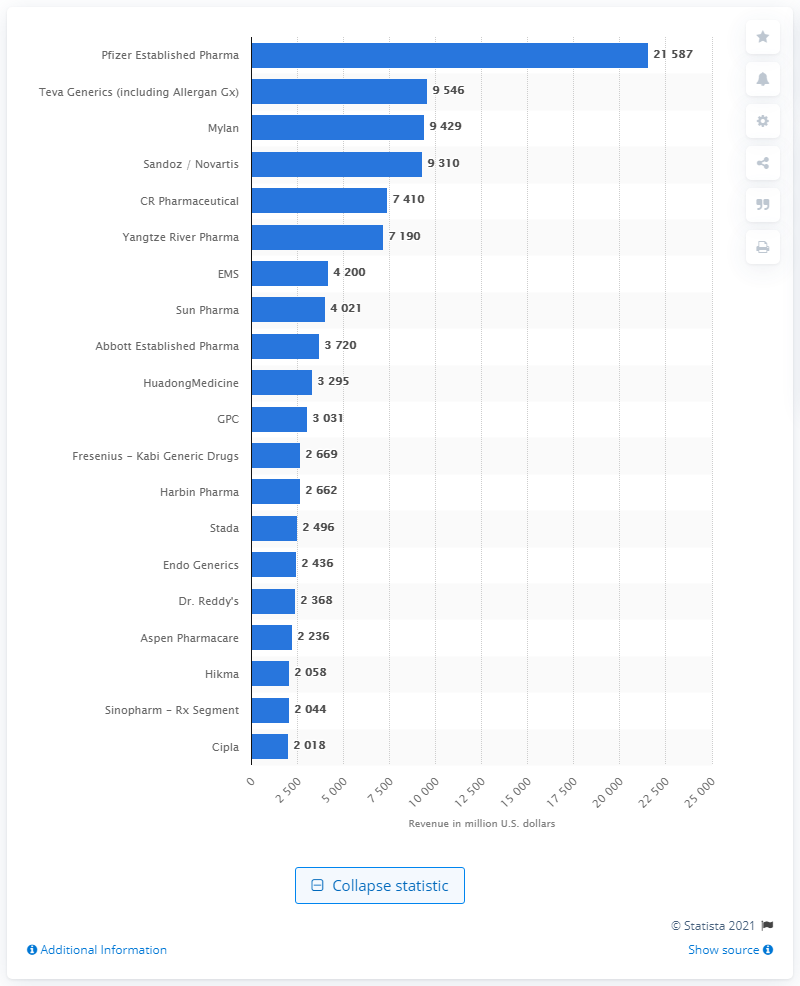List a handful of essential elements in this visual. Pfizer Established Pharma's revenue in 2015 was 21,587. 